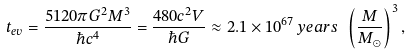<formula> <loc_0><loc_0><loc_500><loc_500>t _ { e v } = { \frac { 5 1 2 0 \pi G ^ { 2 } M ^ { 3 } } { \hbar { c } ^ { 4 } } } = { \frac { 4 8 0 c ^ { 2 } V } { \hbar { G } } } \approx 2 . 1 \times 1 0 ^ { 6 7 } \, { y e a r s } \ \left ( { \frac { M } { M _ { \odot } } } \right ) ^ { 3 } ,</formula> 